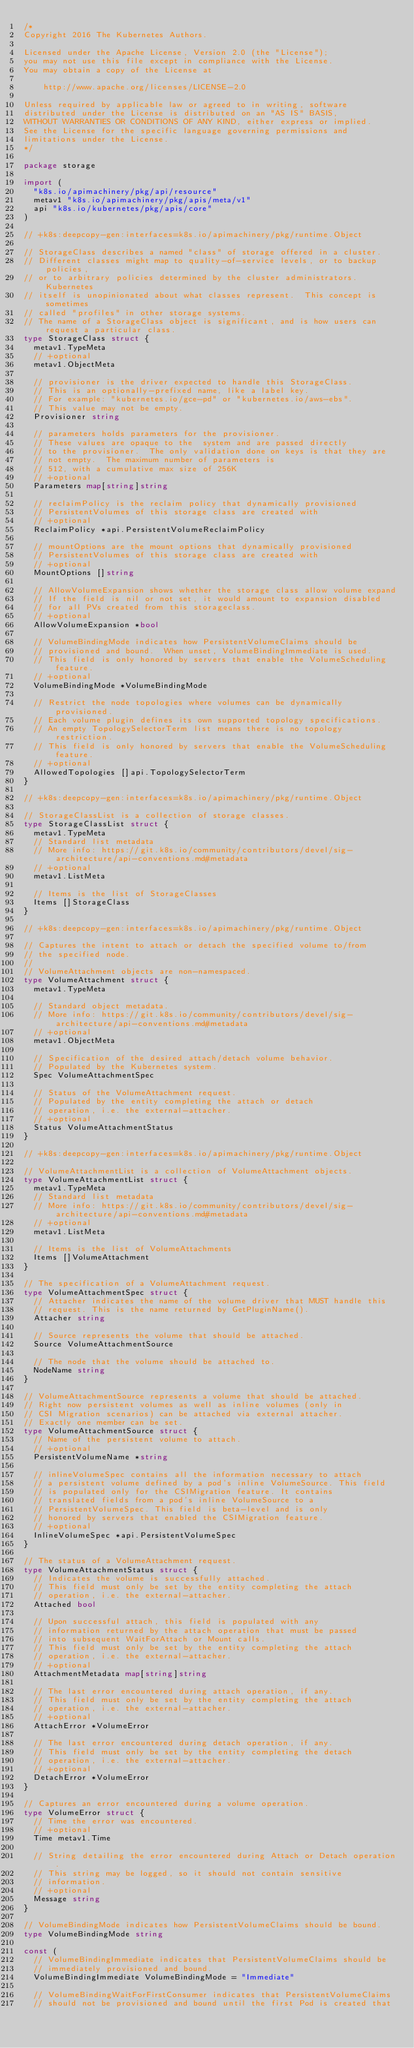Convert code to text. <code><loc_0><loc_0><loc_500><loc_500><_Go_>/*
Copyright 2016 The Kubernetes Authors.

Licensed under the Apache License, Version 2.0 (the "License");
you may not use this file except in compliance with the License.
You may obtain a copy of the License at

    http://www.apache.org/licenses/LICENSE-2.0

Unless required by applicable law or agreed to in writing, software
distributed under the License is distributed on an "AS IS" BASIS,
WITHOUT WARRANTIES OR CONDITIONS OF ANY KIND, either express or implied.
See the License for the specific language governing permissions and
limitations under the License.
*/

package storage

import (
	"k8s.io/apimachinery/pkg/api/resource"
	metav1 "k8s.io/apimachinery/pkg/apis/meta/v1"
	api "k8s.io/kubernetes/pkg/apis/core"
)

// +k8s:deepcopy-gen:interfaces=k8s.io/apimachinery/pkg/runtime.Object

// StorageClass describes a named "class" of storage offered in a cluster.
// Different classes might map to quality-of-service levels, or to backup policies,
// or to arbitrary policies determined by the cluster administrators.  Kubernetes
// itself is unopinionated about what classes represent.  This concept is sometimes
// called "profiles" in other storage systems.
// The name of a StorageClass object is significant, and is how users can request a particular class.
type StorageClass struct {
	metav1.TypeMeta
	// +optional
	metav1.ObjectMeta

	// provisioner is the driver expected to handle this StorageClass.
	// This is an optionally-prefixed name, like a label key.
	// For example: "kubernetes.io/gce-pd" or "kubernetes.io/aws-ebs".
	// This value may not be empty.
	Provisioner string

	// parameters holds parameters for the provisioner.
	// These values are opaque to the  system and are passed directly
	// to the provisioner.  The only validation done on keys is that they are
	// not empty.  The maximum number of parameters is
	// 512, with a cumulative max size of 256K
	// +optional
	Parameters map[string]string

	// reclaimPolicy is the reclaim policy that dynamically provisioned
	// PersistentVolumes of this storage class are created with
	// +optional
	ReclaimPolicy *api.PersistentVolumeReclaimPolicy

	// mountOptions are the mount options that dynamically provisioned
	// PersistentVolumes of this storage class are created with
	// +optional
	MountOptions []string

	// AllowVolumeExpansion shows whether the storage class allow volume expand
	// If the field is nil or not set, it would amount to expansion disabled
	// for all PVs created from this storageclass.
	// +optional
	AllowVolumeExpansion *bool

	// VolumeBindingMode indicates how PersistentVolumeClaims should be
	// provisioned and bound.  When unset, VolumeBindingImmediate is used.
	// This field is only honored by servers that enable the VolumeScheduling feature.
	// +optional
	VolumeBindingMode *VolumeBindingMode

	// Restrict the node topologies where volumes can be dynamically provisioned.
	// Each volume plugin defines its own supported topology specifications.
	// An empty TopologySelectorTerm list means there is no topology restriction.
	// This field is only honored by servers that enable the VolumeScheduling feature.
	// +optional
	AllowedTopologies []api.TopologySelectorTerm
}

// +k8s:deepcopy-gen:interfaces=k8s.io/apimachinery/pkg/runtime.Object

// StorageClassList is a collection of storage classes.
type StorageClassList struct {
	metav1.TypeMeta
	// Standard list metadata
	// More info: https://git.k8s.io/community/contributors/devel/sig-architecture/api-conventions.md#metadata
	// +optional
	metav1.ListMeta

	// Items is the list of StorageClasses
	Items []StorageClass
}

// +k8s:deepcopy-gen:interfaces=k8s.io/apimachinery/pkg/runtime.Object

// Captures the intent to attach or detach the specified volume to/from
// the specified node.
//
// VolumeAttachment objects are non-namespaced.
type VolumeAttachment struct {
	metav1.TypeMeta

	// Standard object metadata.
	// More info: https://git.k8s.io/community/contributors/devel/sig-architecture/api-conventions.md#metadata
	// +optional
	metav1.ObjectMeta

	// Specification of the desired attach/detach volume behavior.
	// Populated by the Kubernetes system.
	Spec VolumeAttachmentSpec

	// Status of the VolumeAttachment request.
	// Populated by the entity completing the attach or detach
	// operation, i.e. the external-attacher.
	// +optional
	Status VolumeAttachmentStatus
}

// +k8s:deepcopy-gen:interfaces=k8s.io/apimachinery/pkg/runtime.Object

// VolumeAttachmentList is a collection of VolumeAttachment objects.
type VolumeAttachmentList struct {
	metav1.TypeMeta
	// Standard list metadata
	// More info: https://git.k8s.io/community/contributors/devel/sig-architecture/api-conventions.md#metadata
	// +optional
	metav1.ListMeta

	// Items is the list of VolumeAttachments
	Items []VolumeAttachment
}

// The specification of a VolumeAttachment request.
type VolumeAttachmentSpec struct {
	// Attacher indicates the name of the volume driver that MUST handle this
	// request. This is the name returned by GetPluginName().
	Attacher string

	// Source represents the volume that should be attached.
	Source VolumeAttachmentSource

	// The node that the volume should be attached to.
	NodeName string
}

// VolumeAttachmentSource represents a volume that should be attached.
// Right now persistent volumes as well as inline volumes (only in
// CSI Migration scenarios) can be attached via external attacher.
// Exactly one member can be set.
type VolumeAttachmentSource struct {
	// Name of the persistent volume to attach.
	// +optional
	PersistentVolumeName *string

	// inlineVolumeSpec contains all the information necessary to attach
	// a persistent volume defined by a pod's inline VolumeSource. This field
	// is populated only for the CSIMigration feature. It contains
	// translated fields from a pod's inline VolumeSource to a
	// PersistentVolumeSpec. This field is beta-level and is only
	// honored by servers that enabled the CSIMigration feature.
	// +optional
	InlineVolumeSpec *api.PersistentVolumeSpec
}

// The status of a VolumeAttachment request.
type VolumeAttachmentStatus struct {
	// Indicates the volume is successfully attached.
	// This field must only be set by the entity completing the attach
	// operation, i.e. the external-attacher.
	Attached bool

	// Upon successful attach, this field is populated with any
	// information returned by the attach operation that must be passed
	// into subsequent WaitForAttach or Mount calls.
	// This field must only be set by the entity completing the attach
	// operation, i.e. the external-attacher.
	// +optional
	AttachmentMetadata map[string]string

	// The last error encountered during attach operation, if any.
	// This field must only be set by the entity completing the attach
	// operation, i.e. the external-attacher.
	// +optional
	AttachError *VolumeError

	// The last error encountered during detach operation, if any.
	// This field must only be set by the entity completing the detach
	// operation, i.e. the external-attacher.
	// +optional
	DetachError *VolumeError
}

// Captures an error encountered during a volume operation.
type VolumeError struct {
	// Time the error was encountered.
	// +optional
	Time metav1.Time

	// String detailing the error encountered during Attach or Detach operation.
	// This string may be logged, so it should not contain sensitive
	// information.
	// +optional
	Message string
}

// VolumeBindingMode indicates how PersistentVolumeClaims should be bound.
type VolumeBindingMode string

const (
	// VolumeBindingImmediate indicates that PersistentVolumeClaims should be
	// immediately provisioned and bound.
	VolumeBindingImmediate VolumeBindingMode = "Immediate"

	// VolumeBindingWaitForFirstConsumer indicates that PersistentVolumeClaims
	// should not be provisioned and bound until the first Pod is created that</code> 